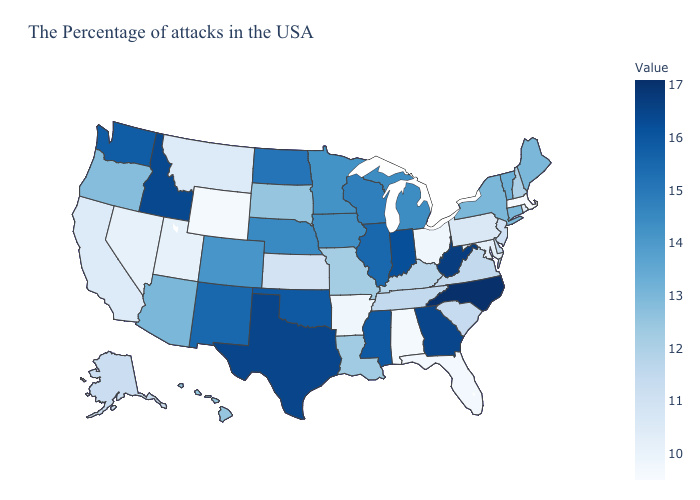Which states hav the highest value in the MidWest?
Give a very brief answer. Indiana. Which states have the lowest value in the USA?
Keep it brief. Massachusetts. Among the states that border South Dakota , does Nebraska have the lowest value?
Concise answer only. No. Does Pennsylvania have the lowest value in the USA?
Write a very short answer. No. Does Illinois have the highest value in the MidWest?
Quick response, please. No. Among the states that border Michigan , does Ohio have the highest value?
Short answer required. No. 